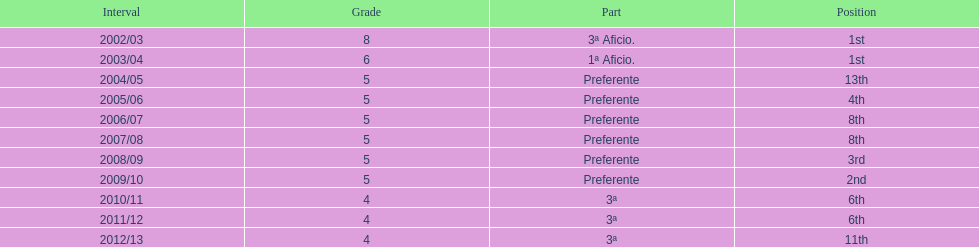What place was 1a aficio and 3a aficio? 1st. 